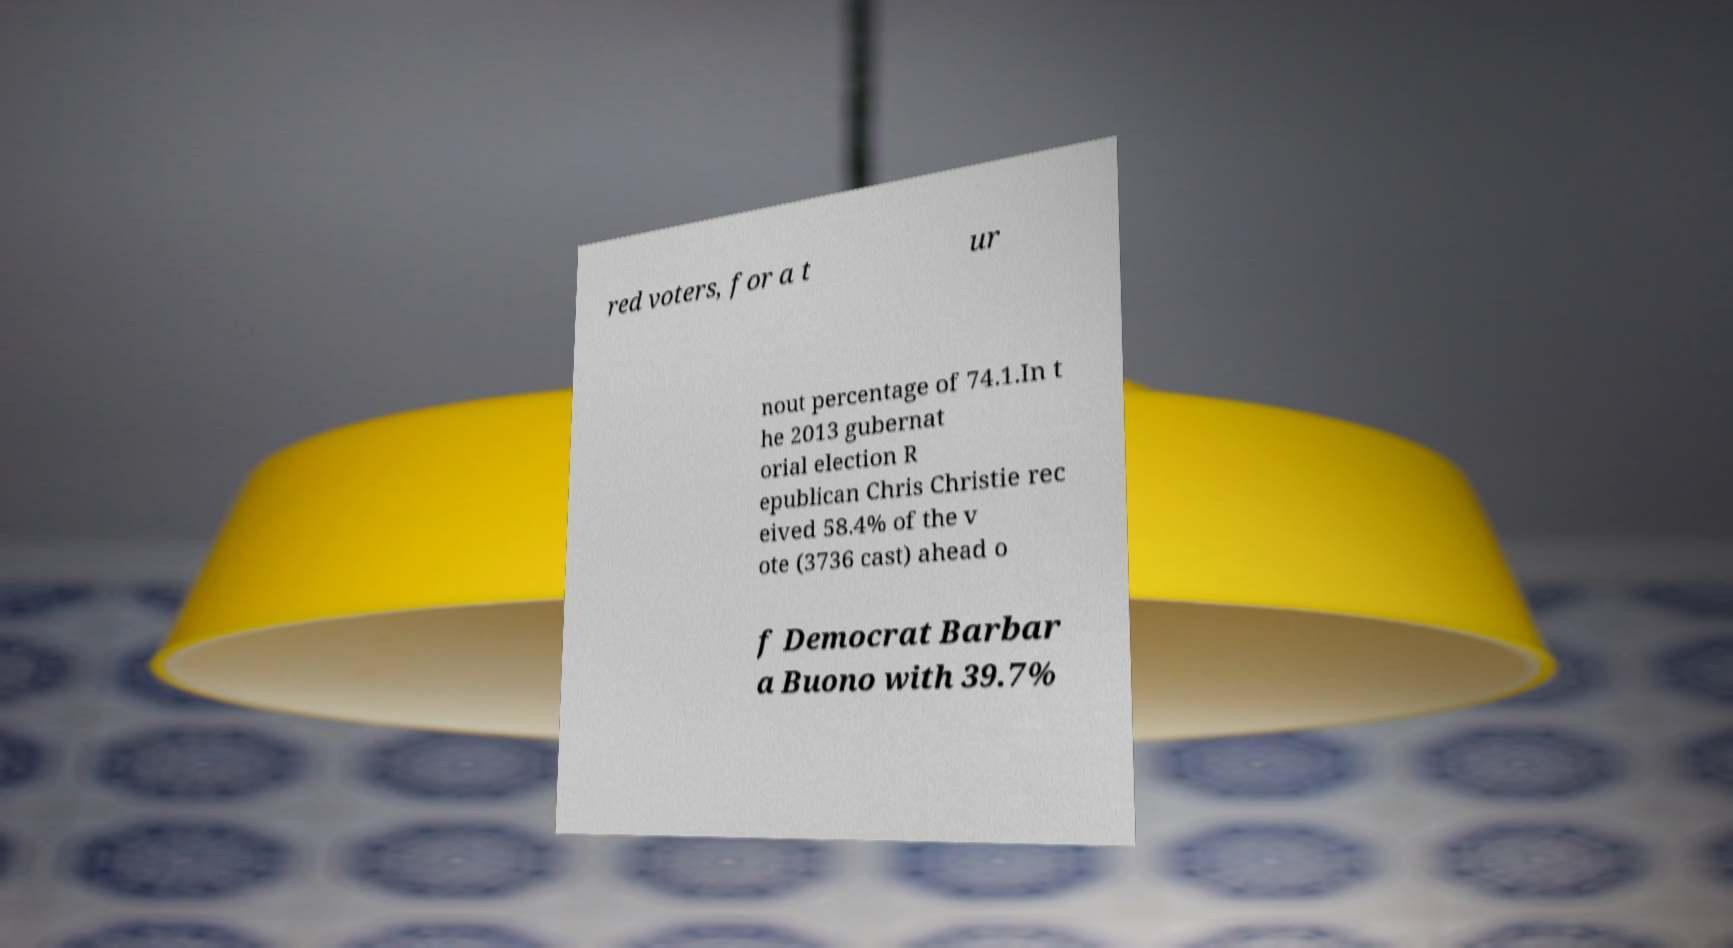Could you extract and type out the text from this image? red voters, for a t ur nout percentage of 74.1.In t he 2013 gubernat orial election R epublican Chris Christie rec eived 58.4% of the v ote (3736 cast) ahead o f Democrat Barbar a Buono with 39.7% 